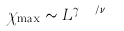<formula> <loc_0><loc_0><loc_500><loc_500>\chi _ { \max } \sim L ^ { \gamma _ { m o n } / \nu _ { m o n } }</formula> 